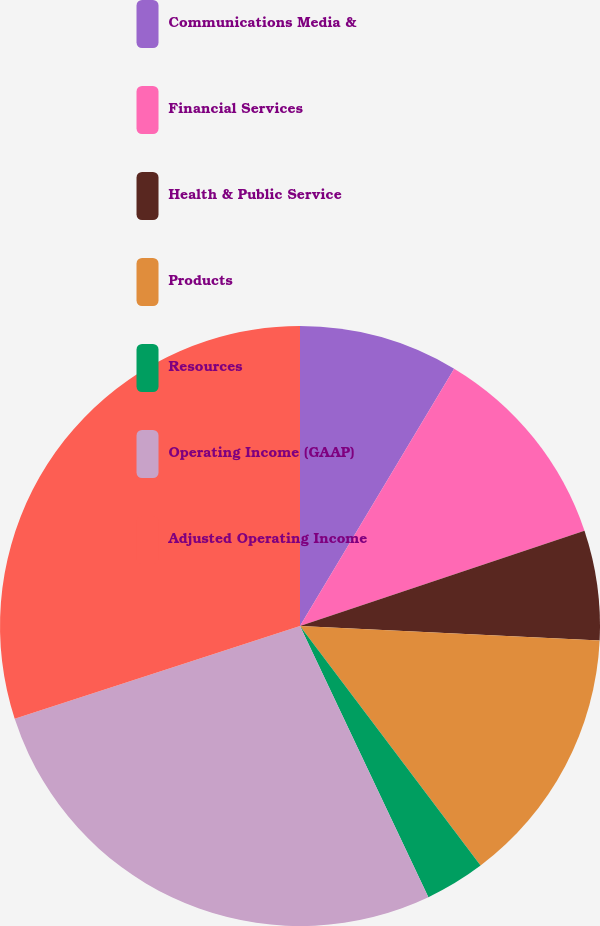<chart> <loc_0><loc_0><loc_500><loc_500><pie_chart><fcel>Communications Media &<fcel>Financial Services<fcel>Health & Public Service<fcel>Products<fcel>Resources<fcel>Operating Income (GAAP)<fcel>Adjusted Operating Income<nl><fcel>8.59%<fcel>11.27%<fcel>5.92%<fcel>13.95%<fcel>3.24%<fcel>27.04%<fcel>30.01%<nl></chart> 